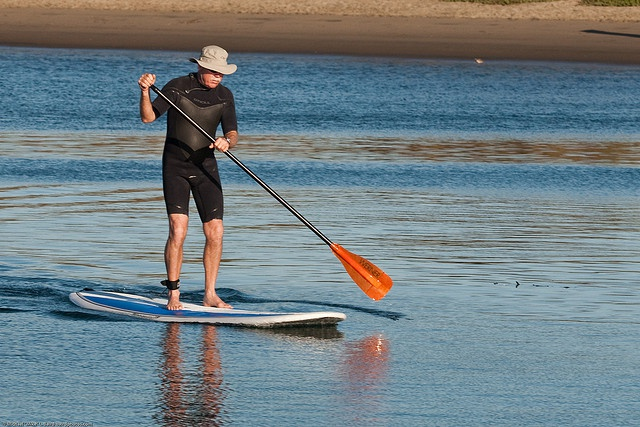Describe the objects in this image and their specific colors. I can see people in tan, black, salmon, and maroon tones, surfboard in tan, lightgray, blue, darkgray, and gray tones, and bird in tan and gray tones in this image. 